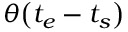Convert formula to latex. <formula><loc_0><loc_0><loc_500><loc_500>\theta \left ( t _ { e } - t _ { s } \right )</formula> 